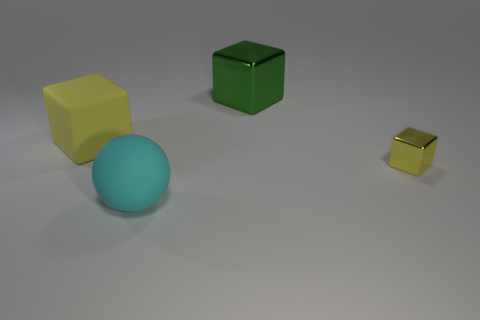Add 1 big blue metal objects. How many objects exist? 5 Subtract all cubes. How many objects are left? 1 Subtract all large shiny objects. Subtract all big green blocks. How many objects are left? 2 Add 2 tiny things. How many tiny things are left? 3 Add 2 big green things. How many big green things exist? 3 Subtract 0 cyan cubes. How many objects are left? 4 